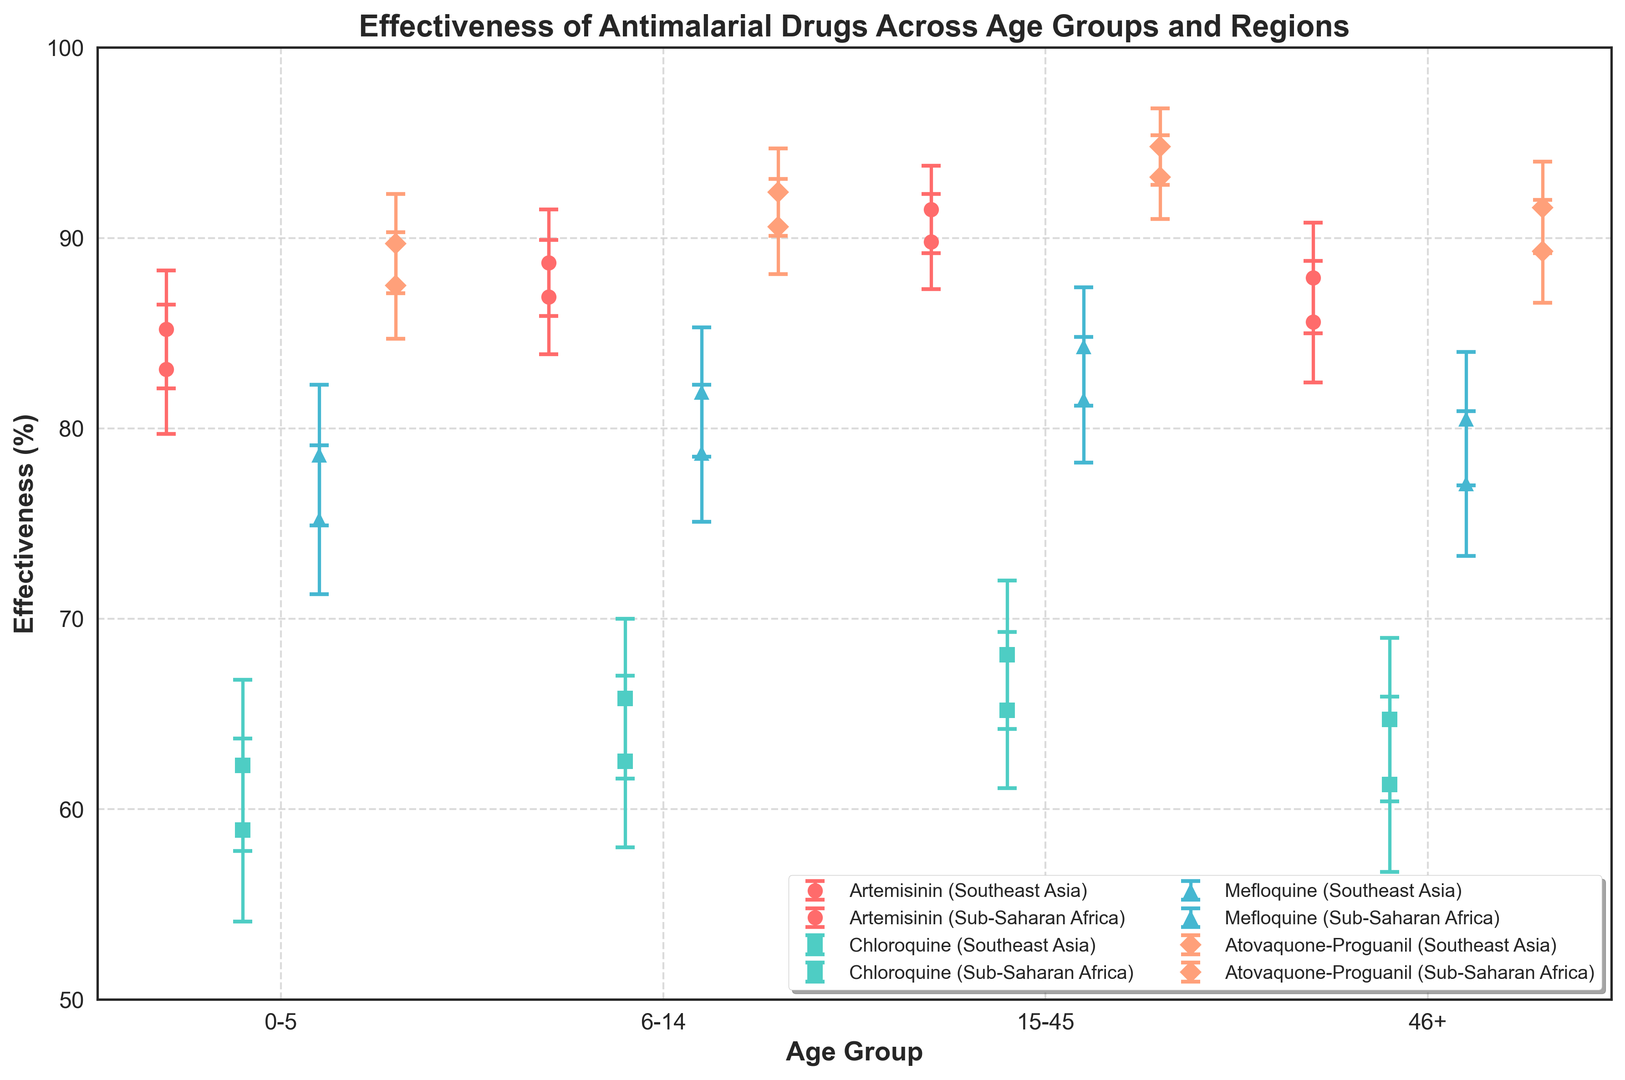Which group shows the highest effectiveness for Atovaquone-Proguanil? The highest effectiveness should be observed for the 15-45 age group in Southeast Asia. We look at the Atovaquone-Proguanil data points across age groups and regions and find the value with the highest percentage.
Answer: 15-45 age group in Southeast Asia What is the difference in effectiveness between Artemisinin and Chloroquine for the 0-5 age group in Southeast Asia? First, find the effectiveness of Artemisinin for the 0-5 age group in Southeast Asia (85.2%). Then, find the effectiveness of Chloroquine for the same age group and region (62.3%). Subtract the effectiveness of Chloroquine from that of Artemisinin (85.2 - 62.3).
Answer: 22.9% Which region shows higher effectiveness for Mefloquine in the 46+ age group? Compare the effectiveness values of Mefloquine in the 46+ age group between Southeast Asia (80.5%) and Sub-Saharan Africa (77.1%). The region with the higher effectiveness is Southeast Asia.
Answer: Southeast Asia What is the average effectiveness of Artemisinin for all age groups in Sub-Saharan Africa? Add the effectiveness values given for each age group in Sub-Saharan Africa (83.1%, 86.9%, 89.8%, 85.6%). Then calculate the average by dividing by the number of age groups (4). The calculation is (83.1 + 86.9 + 89.8 + 85.6) / 4.
Answer: 86.35% Which drug has the lowest effectiveness for the 6-14 age group in Southeast Asia? Examine the effectiveness percentages of all drugs for the 6-14 age group in Southeast Asia. Artemisinin (88.7%), Chloroquine (65.8%), Mefloquine (81.9%), Atovaquone-Proguanil (92.4%). The lowest percentage is for Chloroquine.
Answer: Chloroquine How does the effectiveness of Atovaquone-Proguanil in Sub-Saharan Africa compare to Artemisinin for the same region in the 0-5 age group? Compare the effectiveness values of Atovaquone-Proguanil (87.5%) and Artemisinin (83.1%) for the 0-5 age group in Sub-Saharan Africa. Atovaquone-Proguanil has a higher effectiveness than Artemisinin.
Answer: Atovaquone-Proguanil is higher What is the combined effectiveness of Chloroquine for ages 15-45 and 46+ in Southeast Asia? Add the effectiveness values of Chloroquine for the 15-45 age group (68.1%) and 46+ age group (64.7%) in Southeast Asia. The calculation is 68.1 + 64.7.
Answer: 132.8% Does Mefloquine show consistently higher effectiveness than Chloroquine for all age groups in Sub-Saharan Africa? Compare the values of Mefloquine and Chloroquine side by side for each age group in Sub-Saharan Africa. Mefloquine consistently has higher effectiveness than Chloroquine: 75.2 > 58.9, 78.7 > 62.5, 81.5 > 65.2, 77.1 > 61.3.
Answer: Yes Which age group shows the smallest range of effectiveness for Artemisinin in Southeast Asia? Calculate the range (max - min) of effectiveness for Artemisinin in each age group by subtracting the minimum value from the maximum in Southeast Asia. The ranges are: 0-5 (88.7 - 85.2 = 3.5), 6-14 (91.5 - 88.7 = 2.8), 15-45 (91.5 - 88.7 = 2.8), 46+ (91.5 - 87.9 = 3.6). The smallest range is 6-14 and 15-45.
Answer: 6-14 and 15-45 